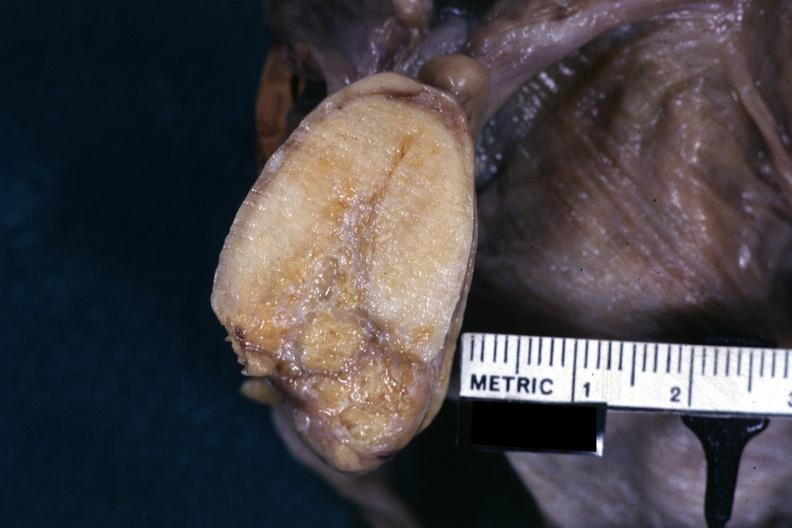what is present?
Answer the question using a single word or phrase. Thecoma 